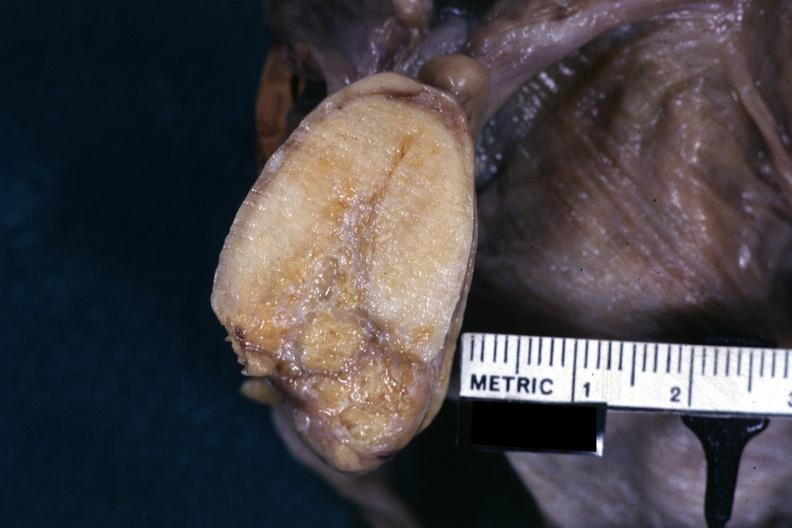what is present?
Answer the question using a single word or phrase. Thecoma 